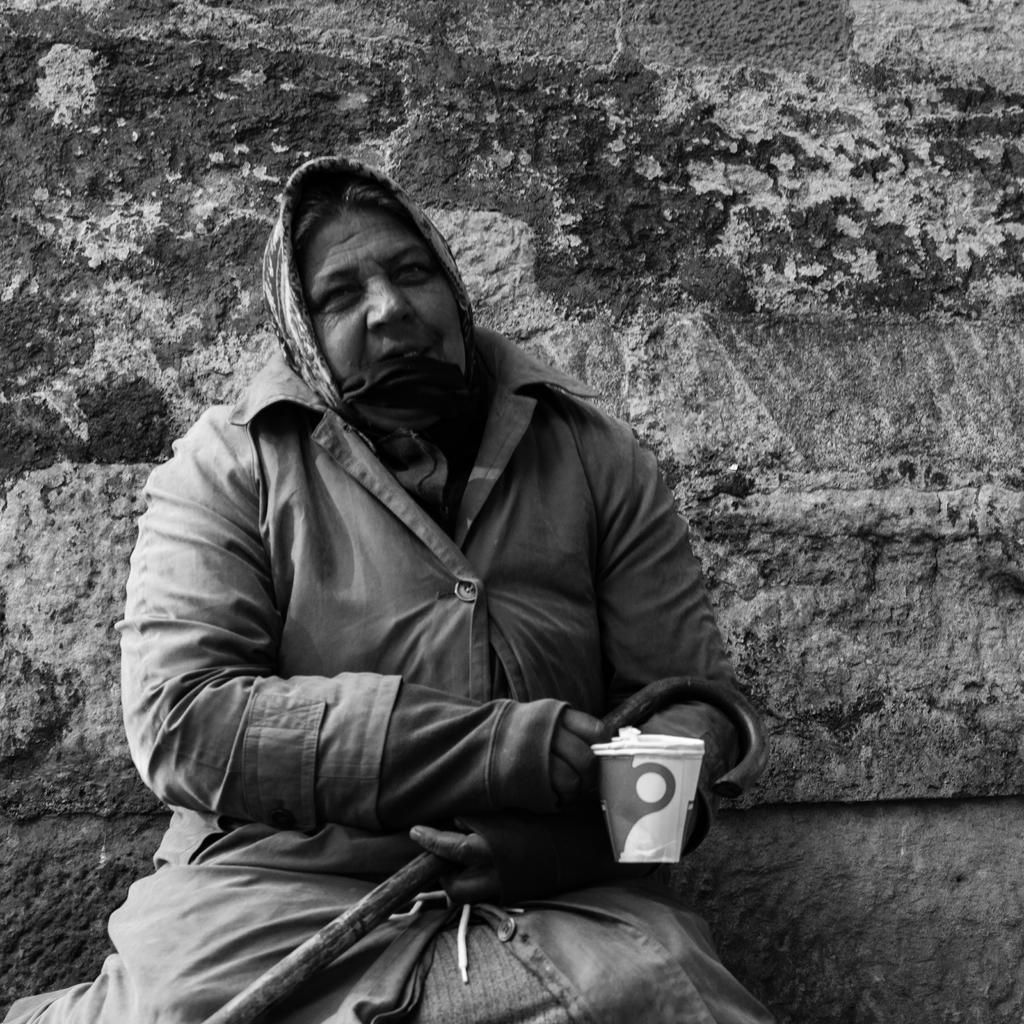What is the woman doing in the picture? The woman is sitting in the picture. What is the woman holding in her right hand? The woman is holding a cup with her right hand. What is the woman holding in her left hand? The woman is holding a stick with her left hand. What type of clothing is the woman wearing? The woman is wearing a coat. What type of clover is the woman holding in her left hand? There is no clover present in the image; the woman is holding a stick. How long did the fight between the woman and the man last? There is no man or fight present in the image; it only features a woman sitting with a cup and a stick. 